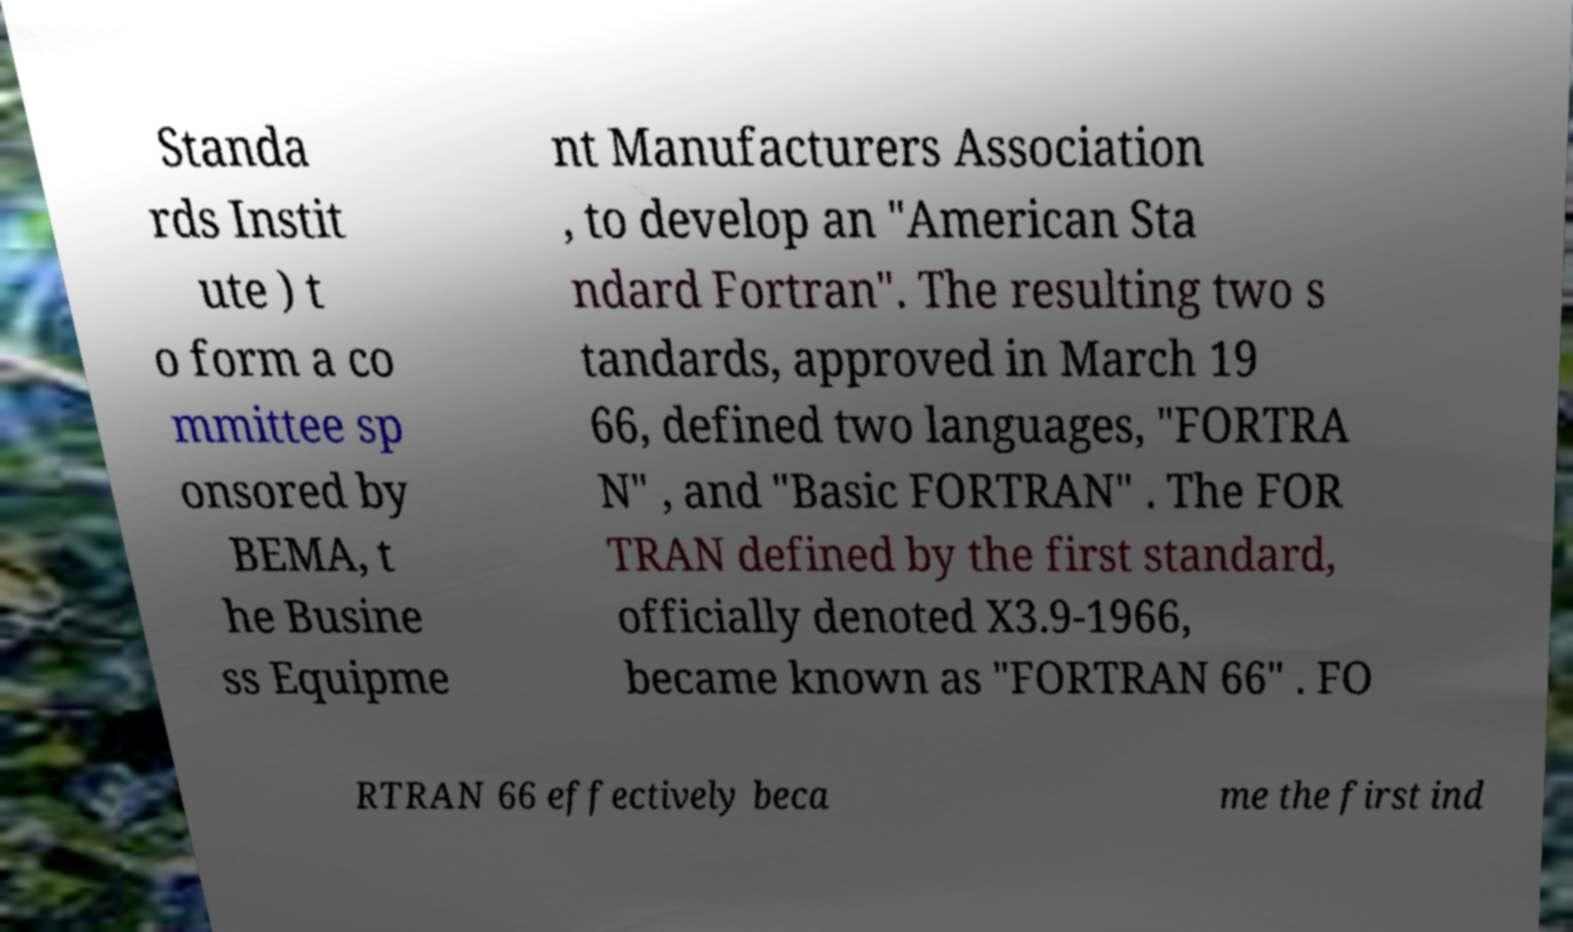For documentation purposes, I need the text within this image transcribed. Could you provide that? Standa rds Instit ute ) t o form a co mmittee sp onsored by BEMA, t he Busine ss Equipme nt Manufacturers Association , to develop an "American Sta ndard Fortran". The resulting two s tandards, approved in March 19 66, defined two languages, "FORTRA N" , and "Basic FORTRAN" . The FOR TRAN defined by the first standard, officially denoted X3.9-1966, became known as "FORTRAN 66" . FO RTRAN 66 effectively beca me the first ind 